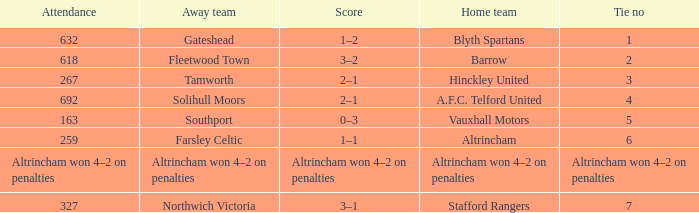Which team playing on their home ground had 2 ties? Barrow. 